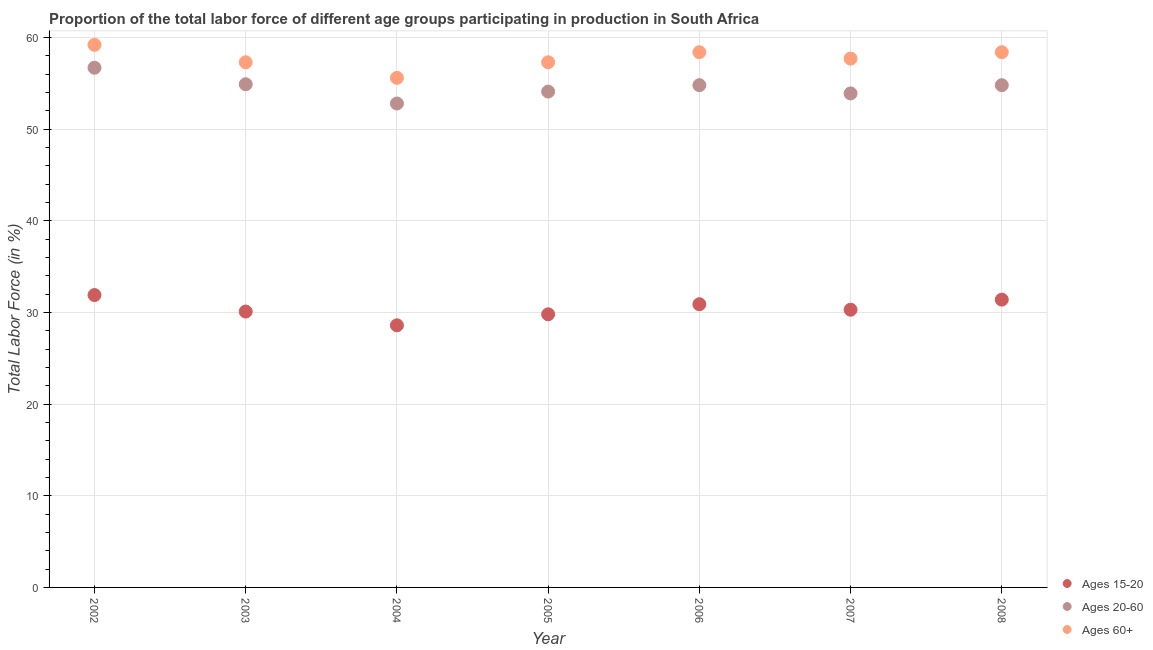How many different coloured dotlines are there?
Your answer should be compact. 3. Is the number of dotlines equal to the number of legend labels?
Keep it short and to the point. Yes. What is the percentage of labor force above age 60 in 2006?
Keep it short and to the point. 58.4. Across all years, what is the maximum percentage of labor force within the age group 20-60?
Give a very brief answer. 56.7. Across all years, what is the minimum percentage of labor force above age 60?
Ensure brevity in your answer.  55.6. In which year was the percentage of labor force within the age group 20-60 minimum?
Your answer should be very brief. 2004. What is the total percentage of labor force within the age group 20-60 in the graph?
Provide a succinct answer. 382. What is the difference between the percentage of labor force within the age group 20-60 in 2007 and the percentage of labor force within the age group 15-20 in 2002?
Your response must be concise. 22. What is the average percentage of labor force above age 60 per year?
Offer a very short reply. 57.7. In the year 2002, what is the difference between the percentage of labor force within the age group 20-60 and percentage of labor force within the age group 15-20?
Give a very brief answer. 24.8. In how many years, is the percentage of labor force within the age group 20-60 greater than 32 %?
Your answer should be compact. 7. What is the ratio of the percentage of labor force within the age group 20-60 in 2004 to that in 2006?
Make the answer very short. 0.96. Is the percentage of labor force within the age group 20-60 in 2005 less than that in 2008?
Keep it short and to the point. Yes. What is the difference between the highest and the lowest percentage of labor force within the age group 15-20?
Provide a succinct answer. 3.3. In how many years, is the percentage of labor force within the age group 15-20 greater than the average percentage of labor force within the age group 15-20 taken over all years?
Ensure brevity in your answer.  3. Is the percentage of labor force above age 60 strictly less than the percentage of labor force within the age group 15-20 over the years?
Offer a very short reply. No. How many dotlines are there?
Keep it short and to the point. 3. How many years are there in the graph?
Offer a very short reply. 7. What is the difference between two consecutive major ticks on the Y-axis?
Make the answer very short. 10. Where does the legend appear in the graph?
Give a very brief answer. Bottom right. How many legend labels are there?
Your response must be concise. 3. How are the legend labels stacked?
Offer a terse response. Vertical. What is the title of the graph?
Your answer should be very brief. Proportion of the total labor force of different age groups participating in production in South Africa. Does "Taxes on income" appear as one of the legend labels in the graph?
Make the answer very short. No. What is the Total Labor Force (in %) of Ages 15-20 in 2002?
Make the answer very short. 31.9. What is the Total Labor Force (in %) of Ages 20-60 in 2002?
Your answer should be very brief. 56.7. What is the Total Labor Force (in %) in Ages 60+ in 2002?
Make the answer very short. 59.2. What is the Total Labor Force (in %) of Ages 15-20 in 2003?
Ensure brevity in your answer.  30.1. What is the Total Labor Force (in %) of Ages 20-60 in 2003?
Your answer should be very brief. 54.9. What is the Total Labor Force (in %) of Ages 60+ in 2003?
Provide a succinct answer. 57.3. What is the Total Labor Force (in %) of Ages 15-20 in 2004?
Your answer should be compact. 28.6. What is the Total Labor Force (in %) of Ages 20-60 in 2004?
Keep it short and to the point. 52.8. What is the Total Labor Force (in %) of Ages 60+ in 2004?
Offer a terse response. 55.6. What is the Total Labor Force (in %) in Ages 15-20 in 2005?
Provide a short and direct response. 29.8. What is the Total Labor Force (in %) of Ages 20-60 in 2005?
Your answer should be very brief. 54.1. What is the Total Labor Force (in %) in Ages 60+ in 2005?
Keep it short and to the point. 57.3. What is the Total Labor Force (in %) in Ages 15-20 in 2006?
Your answer should be very brief. 30.9. What is the Total Labor Force (in %) in Ages 20-60 in 2006?
Your response must be concise. 54.8. What is the Total Labor Force (in %) in Ages 60+ in 2006?
Your answer should be very brief. 58.4. What is the Total Labor Force (in %) in Ages 15-20 in 2007?
Provide a short and direct response. 30.3. What is the Total Labor Force (in %) of Ages 20-60 in 2007?
Make the answer very short. 53.9. What is the Total Labor Force (in %) of Ages 60+ in 2007?
Offer a very short reply. 57.7. What is the Total Labor Force (in %) of Ages 15-20 in 2008?
Give a very brief answer. 31.4. What is the Total Labor Force (in %) of Ages 20-60 in 2008?
Offer a very short reply. 54.8. What is the Total Labor Force (in %) of Ages 60+ in 2008?
Keep it short and to the point. 58.4. Across all years, what is the maximum Total Labor Force (in %) of Ages 15-20?
Ensure brevity in your answer.  31.9. Across all years, what is the maximum Total Labor Force (in %) of Ages 20-60?
Make the answer very short. 56.7. Across all years, what is the maximum Total Labor Force (in %) of Ages 60+?
Offer a very short reply. 59.2. Across all years, what is the minimum Total Labor Force (in %) of Ages 15-20?
Make the answer very short. 28.6. Across all years, what is the minimum Total Labor Force (in %) of Ages 20-60?
Give a very brief answer. 52.8. Across all years, what is the minimum Total Labor Force (in %) of Ages 60+?
Offer a terse response. 55.6. What is the total Total Labor Force (in %) of Ages 15-20 in the graph?
Provide a succinct answer. 213. What is the total Total Labor Force (in %) in Ages 20-60 in the graph?
Provide a short and direct response. 382. What is the total Total Labor Force (in %) of Ages 60+ in the graph?
Provide a succinct answer. 403.9. What is the difference between the Total Labor Force (in %) of Ages 15-20 in 2002 and that in 2004?
Offer a very short reply. 3.3. What is the difference between the Total Labor Force (in %) in Ages 20-60 in 2002 and that in 2004?
Offer a terse response. 3.9. What is the difference between the Total Labor Force (in %) in Ages 20-60 in 2002 and that in 2005?
Make the answer very short. 2.6. What is the difference between the Total Labor Force (in %) in Ages 20-60 in 2002 and that in 2006?
Ensure brevity in your answer.  1.9. What is the difference between the Total Labor Force (in %) of Ages 60+ in 2002 and that in 2006?
Make the answer very short. 0.8. What is the difference between the Total Labor Force (in %) of Ages 15-20 in 2002 and that in 2007?
Your answer should be compact. 1.6. What is the difference between the Total Labor Force (in %) of Ages 20-60 in 2002 and that in 2007?
Provide a short and direct response. 2.8. What is the difference between the Total Labor Force (in %) in Ages 60+ in 2002 and that in 2007?
Your response must be concise. 1.5. What is the difference between the Total Labor Force (in %) of Ages 15-20 in 2002 and that in 2008?
Provide a short and direct response. 0.5. What is the difference between the Total Labor Force (in %) in Ages 20-60 in 2002 and that in 2008?
Keep it short and to the point. 1.9. What is the difference between the Total Labor Force (in %) in Ages 60+ in 2002 and that in 2008?
Your answer should be very brief. 0.8. What is the difference between the Total Labor Force (in %) of Ages 20-60 in 2003 and that in 2004?
Your answer should be compact. 2.1. What is the difference between the Total Labor Force (in %) in Ages 60+ in 2003 and that in 2004?
Offer a very short reply. 1.7. What is the difference between the Total Labor Force (in %) in Ages 20-60 in 2003 and that in 2006?
Your answer should be compact. 0.1. What is the difference between the Total Labor Force (in %) in Ages 60+ in 2003 and that in 2006?
Provide a short and direct response. -1.1. What is the difference between the Total Labor Force (in %) in Ages 15-20 in 2003 and that in 2007?
Give a very brief answer. -0.2. What is the difference between the Total Labor Force (in %) of Ages 60+ in 2003 and that in 2007?
Keep it short and to the point. -0.4. What is the difference between the Total Labor Force (in %) in Ages 15-20 in 2003 and that in 2008?
Provide a succinct answer. -1.3. What is the difference between the Total Labor Force (in %) in Ages 20-60 in 2003 and that in 2008?
Offer a terse response. 0.1. What is the difference between the Total Labor Force (in %) of Ages 60+ in 2003 and that in 2008?
Your answer should be compact. -1.1. What is the difference between the Total Labor Force (in %) of Ages 15-20 in 2004 and that in 2005?
Ensure brevity in your answer.  -1.2. What is the difference between the Total Labor Force (in %) of Ages 20-60 in 2004 and that in 2005?
Your answer should be very brief. -1.3. What is the difference between the Total Labor Force (in %) of Ages 15-20 in 2004 and that in 2006?
Your response must be concise. -2.3. What is the difference between the Total Labor Force (in %) of Ages 15-20 in 2004 and that in 2007?
Provide a short and direct response. -1.7. What is the difference between the Total Labor Force (in %) of Ages 20-60 in 2004 and that in 2007?
Give a very brief answer. -1.1. What is the difference between the Total Labor Force (in %) in Ages 60+ in 2004 and that in 2007?
Your answer should be very brief. -2.1. What is the difference between the Total Labor Force (in %) of Ages 60+ in 2004 and that in 2008?
Keep it short and to the point. -2.8. What is the difference between the Total Labor Force (in %) of Ages 20-60 in 2005 and that in 2006?
Offer a very short reply. -0.7. What is the difference between the Total Labor Force (in %) in Ages 60+ in 2005 and that in 2006?
Your answer should be very brief. -1.1. What is the difference between the Total Labor Force (in %) in Ages 60+ in 2005 and that in 2007?
Ensure brevity in your answer.  -0.4. What is the difference between the Total Labor Force (in %) of Ages 15-20 in 2005 and that in 2008?
Offer a terse response. -1.6. What is the difference between the Total Labor Force (in %) of Ages 60+ in 2005 and that in 2008?
Give a very brief answer. -1.1. What is the difference between the Total Labor Force (in %) of Ages 20-60 in 2006 and that in 2007?
Your answer should be very brief. 0.9. What is the difference between the Total Labor Force (in %) in Ages 15-20 in 2006 and that in 2008?
Give a very brief answer. -0.5. What is the difference between the Total Labor Force (in %) of Ages 60+ in 2006 and that in 2008?
Your response must be concise. 0. What is the difference between the Total Labor Force (in %) in Ages 15-20 in 2007 and that in 2008?
Offer a very short reply. -1.1. What is the difference between the Total Labor Force (in %) of Ages 15-20 in 2002 and the Total Labor Force (in %) of Ages 60+ in 2003?
Offer a very short reply. -25.4. What is the difference between the Total Labor Force (in %) in Ages 20-60 in 2002 and the Total Labor Force (in %) in Ages 60+ in 2003?
Make the answer very short. -0.6. What is the difference between the Total Labor Force (in %) in Ages 15-20 in 2002 and the Total Labor Force (in %) in Ages 20-60 in 2004?
Ensure brevity in your answer.  -20.9. What is the difference between the Total Labor Force (in %) of Ages 15-20 in 2002 and the Total Labor Force (in %) of Ages 60+ in 2004?
Offer a terse response. -23.7. What is the difference between the Total Labor Force (in %) in Ages 20-60 in 2002 and the Total Labor Force (in %) in Ages 60+ in 2004?
Keep it short and to the point. 1.1. What is the difference between the Total Labor Force (in %) of Ages 15-20 in 2002 and the Total Labor Force (in %) of Ages 20-60 in 2005?
Your answer should be very brief. -22.2. What is the difference between the Total Labor Force (in %) of Ages 15-20 in 2002 and the Total Labor Force (in %) of Ages 60+ in 2005?
Provide a short and direct response. -25.4. What is the difference between the Total Labor Force (in %) in Ages 15-20 in 2002 and the Total Labor Force (in %) in Ages 20-60 in 2006?
Your response must be concise. -22.9. What is the difference between the Total Labor Force (in %) of Ages 15-20 in 2002 and the Total Labor Force (in %) of Ages 60+ in 2006?
Make the answer very short. -26.5. What is the difference between the Total Labor Force (in %) in Ages 20-60 in 2002 and the Total Labor Force (in %) in Ages 60+ in 2006?
Make the answer very short. -1.7. What is the difference between the Total Labor Force (in %) in Ages 15-20 in 2002 and the Total Labor Force (in %) in Ages 20-60 in 2007?
Ensure brevity in your answer.  -22. What is the difference between the Total Labor Force (in %) of Ages 15-20 in 2002 and the Total Labor Force (in %) of Ages 60+ in 2007?
Provide a succinct answer. -25.8. What is the difference between the Total Labor Force (in %) in Ages 15-20 in 2002 and the Total Labor Force (in %) in Ages 20-60 in 2008?
Ensure brevity in your answer.  -22.9. What is the difference between the Total Labor Force (in %) of Ages 15-20 in 2002 and the Total Labor Force (in %) of Ages 60+ in 2008?
Keep it short and to the point. -26.5. What is the difference between the Total Labor Force (in %) in Ages 15-20 in 2003 and the Total Labor Force (in %) in Ages 20-60 in 2004?
Offer a terse response. -22.7. What is the difference between the Total Labor Force (in %) in Ages 15-20 in 2003 and the Total Labor Force (in %) in Ages 60+ in 2004?
Ensure brevity in your answer.  -25.5. What is the difference between the Total Labor Force (in %) in Ages 15-20 in 2003 and the Total Labor Force (in %) in Ages 20-60 in 2005?
Give a very brief answer. -24. What is the difference between the Total Labor Force (in %) in Ages 15-20 in 2003 and the Total Labor Force (in %) in Ages 60+ in 2005?
Your answer should be very brief. -27.2. What is the difference between the Total Labor Force (in %) of Ages 20-60 in 2003 and the Total Labor Force (in %) of Ages 60+ in 2005?
Give a very brief answer. -2.4. What is the difference between the Total Labor Force (in %) in Ages 15-20 in 2003 and the Total Labor Force (in %) in Ages 20-60 in 2006?
Keep it short and to the point. -24.7. What is the difference between the Total Labor Force (in %) of Ages 15-20 in 2003 and the Total Labor Force (in %) of Ages 60+ in 2006?
Give a very brief answer. -28.3. What is the difference between the Total Labor Force (in %) in Ages 20-60 in 2003 and the Total Labor Force (in %) in Ages 60+ in 2006?
Your answer should be compact. -3.5. What is the difference between the Total Labor Force (in %) in Ages 15-20 in 2003 and the Total Labor Force (in %) in Ages 20-60 in 2007?
Keep it short and to the point. -23.8. What is the difference between the Total Labor Force (in %) of Ages 15-20 in 2003 and the Total Labor Force (in %) of Ages 60+ in 2007?
Your response must be concise. -27.6. What is the difference between the Total Labor Force (in %) of Ages 20-60 in 2003 and the Total Labor Force (in %) of Ages 60+ in 2007?
Your answer should be compact. -2.8. What is the difference between the Total Labor Force (in %) in Ages 15-20 in 2003 and the Total Labor Force (in %) in Ages 20-60 in 2008?
Provide a succinct answer. -24.7. What is the difference between the Total Labor Force (in %) in Ages 15-20 in 2003 and the Total Labor Force (in %) in Ages 60+ in 2008?
Make the answer very short. -28.3. What is the difference between the Total Labor Force (in %) of Ages 20-60 in 2003 and the Total Labor Force (in %) of Ages 60+ in 2008?
Offer a terse response. -3.5. What is the difference between the Total Labor Force (in %) of Ages 15-20 in 2004 and the Total Labor Force (in %) of Ages 20-60 in 2005?
Make the answer very short. -25.5. What is the difference between the Total Labor Force (in %) in Ages 15-20 in 2004 and the Total Labor Force (in %) in Ages 60+ in 2005?
Ensure brevity in your answer.  -28.7. What is the difference between the Total Labor Force (in %) in Ages 15-20 in 2004 and the Total Labor Force (in %) in Ages 20-60 in 2006?
Provide a succinct answer. -26.2. What is the difference between the Total Labor Force (in %) of Ages 15-20 in 2004 and the Total Labor Force (in %) of Ages 60+ in 2006?
Your response must be concise. -29.8. What is the difference between the Total Labor Force (in %) of Ages 20-60 in 2004 and the Total Labor Force (in %) of Ages 60+ in 2006?
Offer a very short reply. -5.6. What is the difference between the Total Labor Force (in %) in Ages 15-20 in 2004 and the Total Labor Force (in %) in Ages 20-60 in 2007?
Provide a succinct answer. -25.3. What is the difference between the Total Labor Force (in %) of Ages 15-20 in 2004 and the Total Labor Force (in %) of Ages 60+ in 2007?
Keep it short and to the point. -29.1. What is the difference between the Total Labor Force (in %) in Ages 20-60 in 2004 and the Total Labor Force (in %) in Ages 60+ in 2007?
Provide a short and direct response. -4.9. What is the difference between the Total Labor Force (in %) in Ages 15-20 in 2004 and the Total Labor Force (in %) in Ages 20-60 in 2008?
Give a very brief answer. -26.2. What is the difference between the Total Labor Force (in %) of Ages 15-20 in 2004 and the Total Labor Force (in %) of Ages 60+ in 2008?
Ensure brevity in your answer.  -29.8. What is the difference between the Total Labor Force (in %) of Ages 20-60 in 2004 and the Total Labor Force (in %) of Ages 60+ in 2008?
Give a very brief answer. -5.6. What is the difference between the Total Labor Force (in %) of Ages 15-20 in 2005 and the Total Labor Force (in %) of Ages 20-60 in 2006?
Make the answer very short. -25. What is the difference between the Total Labor Force (in %) of Ages 15-20 in 2005 and the Total Labor Force (in %) of Ages 60+ in 2006?
Make the answer very short. -28.6. What is the difference between the Total Labor Force (in %) of Ages 15-20 in 2005 and the Total Labor Force (in %) of Ages 20-60 in 2007?
Provide a short and direct response. -24.1. What is the difference between the Total Labor Force (in %) of Ages 15-20 in 2005 and the Total Labor Force (in %) of Ages 60+ in 2007?
Offer a very short reply. -27.9. What is the difference between the Total Labor Force (in %) in Ages 15-20 in 2005 and the Total Labor Force (in %) in Ages 60+ in 2008?
Provide a short and direct response. -28.6. What is the difference between the Total Labor Force (in %) in Ages 20-60 in 2005 and the Total Labor Force (in %) in Ages 60+ in 2008?
Provide a succinct answer. -4.3. What is the difference between the Total Labor Force (in %) of Ages 15-20 in 2006 and the Total Labor Force (in %) of Ages 20-60 in 2007?
Your answer should be very brief. -23. What is the difference between the Total Labor Force (in %) in Ages 15-20 in 2006 and the Total Labor Force (in %) in Ages 60+ in 2007?
Make the answer very short. -26.8. What is the difference between the Total Labor Force (in %) of Ages 20-60 in 2006 and the Total Labor Force (in %) of Ages 60+ in 2007?
Your answer should be very brief. -2.9. What is the difference between the Total Labor Force (in %) of Ages 15-20 in 2006 and the Total Labor Force (in %) of Ages 20-60 in 2008?
Your answer should be compact. -23.9. What is the difference between the Total Labor Force (in %) in Ages 15-20 in 2006 and the Total Labor Force (in %) in Ages 60+ in 2008?
Your answer should be compact. -27.5. What is the difference between the Total Labor Force (in %) of Ages 20-60 in 2006 and the Total Labor Force (in %) of Ages 60+ in 2008?
Give a very brief answer. -3.6. What is the difference between the Total Labor Force (in %) of Ages 15-20 in 2007 and the Total Labor Force (in %) of Ages 20-60 in 2008?
Your answer should be compact. -24.5. What is the difference between the Total Labor Force (in %) of Ages 15-20 in 2007 and the Total Labor Force (in %) of Ages 60+ in 2008?
Your response must be concise. -28.1. What is the average Total Labor Force (in %) of Ages 15-20 per year?
Keep it short and to the point. 30.43. What is the average Total Labor Force (in %) in Ages 20-60 per year?
Your answer should be very brief. 54.57. What is the average Total Labor Force (in %) of Ages 60+ per year?
Provide a short and direct response. 57.7. In the year 2002, what is the difference between the Total Labor Force (in %) of Ages 15-20 and Total Labor Force (in %) of Ages 20-60?
Provide a succinct answer. -24.8. In the year 2002, what is the difference between the Total Labor Force (in %) of Ages 15-20 and Total Labor Force (in %) of Ages 60+?
Make the answer very short. -27.3. In the year 2002, what is the difference between the Total Labor Force (in %) in Ages 20-60 and Total Labor Force (in %) in Ages 60+?
Your answer should be very brief. -2.5. In the year 2003, what is the difference between the Total Labor Force (in %) of Ages 15-20 and Total Labor Force (in %) of Ages 20-60?
Offer a terse response. -24.8. In the year 2003, what is the difference between the Total Labor Force (in %) in Ages 15-20 and Total Labor Force (in %) in Ages 60+?
Make the answer very short. -27.2. In the year 2003, what is the difference between the Total Labor Force (in %) in Ages 20-60 and Total Labor Force (in %) in Ages 60+?
Your answer should be very brief. -2.4. In the year 2004, what is the difference between the Total Labor Force (in %) of Ages 15-20 and Total Labor Force (in %) of Ages 20-60?
Provide a short and direct response. -24.2. In the year 2004, what is the difference between the Total Labor Force (in %) in Ages 15-20 and Total Labor Force (in %) in Ages 60+?
Provide a succinct answer. -27. In the year 2004, what is the difference between the Total Labor Force (in %) in Ages 20-60 and Total Labor Force (in %) in Ages 60+?
Your answer should be very brief. -2.8. In the year 2005, what is the difference between the Total Labor Force (in %) of Ages 15-20 and Total Labor Force (in %) of Ages 20-60?
Provide a short and direct response. -24.3. In the year 2005, what is the difference between the Total Labor Force (in %) in Ages 15-20 and Total Labor Force (in %) in Ages 60+?
Give a very brief answer. -27.5. In the year 2005, what is the difference between the Total Labor Force (in %) in Ages 20-60 and Total Labor Force (in %) in Ages 60+?
Your response must be concise. -3.2. In the year 2006, what is the difference between the Total Labor Force (in %) of Ages 15-20 and Total Labor Force (in %) of Ages 20-60?
Your response must be concise. -23.9. In the year 2006, what is the difference between the Total Labor Force (in %) of Ages 15-20 and Total Labor Force (in %) of Ages 60+?
Your answer should be very brief. -27.5. In the year 2006, what is the difference between the Total Labor Force (in %) of Ages 20-60 and Total Labor Force (in %) of Ages 60+?
Offer a very short reply. -3.6. In the year 2007, what is the difference between the Total Labor Force (in %) of Ages 15-20 and Total Labor Force (in %) of Ages 20-60?
Keep it short and to the point. -23.6. In the year 2007, what is the difference between the Total Labor Force (in %) of Ages 15-20 and Total Labor Force (in %) of Ages 60+?
Offer a very short reply. -27.4. In the year 2007, what is the difference between the Total Labor Force (in %) of Ages 20-60 and Total Labor Force (in %) of Ages 60+?
Provide a short and direct response. -3.8. In the year 2008, what is the difference between the Total Labor Force (in %) in Ages 15-20 and Total Labor Force (in %) in Ages 20-60?
Offer a very short reply. -23.4. In the year 2008, what is the difference between the Total Labor Force (in %) in Ages 15-20 and Total Labor Force (in %) in Ages 60+?
Provide a short and direct response. -27. What is the ratio of the Total Labor Force (in %) of Ages 15-20 in 2002 to that in 2003?
Offer a terse response. 1.06. What is the ratio of the Total Labor Force (in %) of Ages 20-60 in 2002 to that in 2003?
Give a very brief answer. 1.03. What is the ratio of the Total Labor Force (in %) in Ages 60+ in 2002 to that in 2003?
Offer a terse response. 1.03. What is the ratio of the Total Labor Force (in %) of Ages 15-20 in 2002 to that in 2004?
Ensure brevity in your answer.  1.12. What is the ratio of the Total Labor Force (in %) in Ages 20-60 in 2002 to that in 2004?
Your response must be concise. 1.07. What is the ratio of the Total Labor Force (in %) in Ages 60+ in 2002 to that in 2004?
Your answer should be compact. 1.06. What is the ratio of the Total Labor Force (in %) in Ages 15-20 in 2002 to that in 2005?
Your answer should be compact. 1.07. What is the ratio of the Total Labor Force (in %) in Ages 20-60 in 2002 to that in 2005?
Offer a very short reply. 1.05. What is the ratio of the Total Labor Force (in %) of Ages 60+ in 2002 to that in 2005?
Provide a succinct answer. 1.03. What is the ratio of the Total Labor Force (in %) of Ages 15-20 in 2002 to that in 2006?
Give a very brief answer. 1.03. What is the ratio of the Total Labor Force (in %) in Ages 20-60 in 2002 to that in 2006?
Offer a very short reply. 1.03. What is the ratio of the Total Labor Force (in %) in Ages 60+ in 2002 to that in 2006?
Make the answer very short. 1.01. What is the ratio of the Total Labor Force (in %) in Ages 15-20 in 2002 to that in 2007?
Your answer should be compact. 1.05. What is the ratio of the Total Labor Force (in %) in Ages 20-60 in 2002 to that in 2007?
Offer a very short reply. 1.05. What is the ratio of the Total Labor Force (in %) of Ages 60+ in 2002 to that in 2007?
Your answer should be very brief. 1.03. What is the ratio of the Total Labor Force (in %) of Ages 15-20 in 2002 to that in 2008?
Keep it short and to the point. 1.02. What is the ratio of the Total Labor Force (in %) of Ages 20-60 in 2002 to that in 2008?
Ensure brevity in your answer.  1.03. What is the ratio of the Total Labor Force (in %) of Ages 60+ in 2002 to that in 2008?
Ensure brevity in your answer.  1.01. What is the ratio of the Total Labor Force (in %) of Ages 15-20 in 2003 to that in 2004?
Provide a succinct answer. 1.05. What is the ratio of the Total Labor Force (in %) in Ages 20-60 in 2003 to that in 2004?
Make the answer very short. 1.04. What is the ratio of the Total Labor Force (in %) of Ages 60+ in 2003 to that in 2004?
Provide a succinct answer. 1.03. What is the ratio of the Total Labor Force (in %) in Ages 15-20 in 2003 to that in 2005?
Give a very brief answer. 1.01. What is the ratio of the Total Labor Force (in %) of Ages 20-60 in 2003 to that in 2005?
Offer a terse response. 1.01. What is the ratio of the Total Labor Force (in %) in Ages 15-20 in 2003 to that in 2006?
Give a very brief answer. 0.97. What is the ratio of the Total Labor Force (in %) of Ages 20-60 in 2003 to that in 2006?
Provide a short and direct response. 1. What is the ratio of the Total Labor Force (in %) of Ages 60+ in 2003 to that in 2006?
Provide a short and direct response. 0.98. What is the ratio of the Total Labor Force (in %) in Ages 20-60 in 2003 to that in 2007?
Your answer should be compact. 1.02. What is the ratio of the Total Labor Force (in %) of Ages 15-20 in 2003 to that in 2008?
Your response must be concise. 0.96. What is the ratio of the Total Labor Force (in %) of Ages 60+ in 2003 to that in 2008?
Give a very brief answer. 0.98. What is the ratio of the Total Labor Force (in %) in Ages 15-20 in 2004 to that in 2005?
Give a very brief answer. 0.96. What is the ratio of the Total Labor Force (in %) of Ages 20-60 in 2004 to that in 2005?
Offer a terse response. 0.98. What is the ratio of the Total Labor Force (in %) of Ages 60+ in 2004 to that in 2005?
Ensure brevity in your answer.  0.97. What is the ratio of the Total Labor Force (in %) in Ages 15-20 in 2004 to that in 2006?
Offer a terse response. 0.93. What is the ratio of the Total Labor Force (in %) of Ages 20-60 in 2004 to that in 2006?
Offer a terse response. 0.96. What is the ratio of the Total Labor Force (in %) in Ages 60+ in 2004 to that in 2006?
Provide a short and direct response. 0.95. What is the ratio of the Total Labor Force (in %) in Ages 15-20 in 2004 to that in 2007?
Your answer should be compact. 0.94. What is the ratio of the Total Labor Force (in %) of Ages 20-60 in 2004 to that in 2007?
Your answer should be very brief. 0.98. What is the ratio of the Total Labor Force (in %) in Ages 60+ in 2004 to that in 2007?
Ensure brevity in your answer.  0.96. What is the ratio of the Total Labor Force (in %) of Ages 15-20 in 2004 to that in 2008?
Your response must be concise. 0.91. What is the ratio of the Total Labor Force (in %) in Ages 20-60 in 2004 to that in 2008?
Your answer should be compact. 0.96. What is the ratio of the Total Labor Force (in %) in Ages 60+ in 2004 to that in 2008?
Make the answer very short. 0.95. What is the ratio of the Total Labor Force (in %) of Ages 15-20 in 2005 to that in 2006?
Offer a terse response. 0.96. What is the ratio of the Total Labor Force (in %) in Ages 20-60 in 2005 to that in 2006?
Your answer should be compact. 0.99. What is the ratio of the Total Labor Force (in %) of Ages 60+ in 2005 to that in 2006?
Make the answer very short. 0.98. What is the ratio of the Total Labor Force (in %) in Ages 15-20 in 2005 to that in 2007?
Keep it short and to the point. 0.98. What is the ratio of the Total Labor Force (in %) of Ages 60+ in 2005 to that in 2007?
Keep it short and to the point. 0.99. What is the ratio of the Total Labor Force (in %) in Ages 15-20 in 2005 to that in 2008?
Your answer should be compact. 0.95. What is the ratio of the Total Labor Force (in %) of Ages 20-60 in 2005 to that in 2008?
Your answer should be very brief. 0.99. What is the ratio of the Total Labor Force (in %) of Ages 60+ in 2005 to that in 2008?
Your response must be concise. 0.98. What is the ratio of the Total Labor Force (in %) of Ages 15-20 in 2006 to that in 2007?
Offer a terse response. 1.02. What is the ratio of the Total Labor Force (in %) of Ages 20-60 in 2006 to that in 2007?
Your response must be concise. 1.02. What is the ratio of the Total Labor Force (in %) in Ages 60+ in 2006 to that in 2007?
Make the answer very short. 1.01. What is the ratio of the Total Labor Force (in %) of Ages 15-20 in 2006 to that in 2008?
Keep it short and to the point. 0.98. What is the ratio of the Total Labor Force (in %) of Ages 20-60 in 2007 to that in 2008?
Provide a short and direct response. 0.98. What is the ratio of the Total Labor Force (in %) of Ages 60+ in 2007 to that in 2008?
Provide a short and direct response. 0.99. What is the difference between the highest and the second highest Total Labor Force (in %) in Ages 20-60?
Keep it short and to the point. 1.8. What is the difference between the highest and the lowest Total Labor Force (in %) of Ages 20-60?
Give a very brief answer. 3.9. 